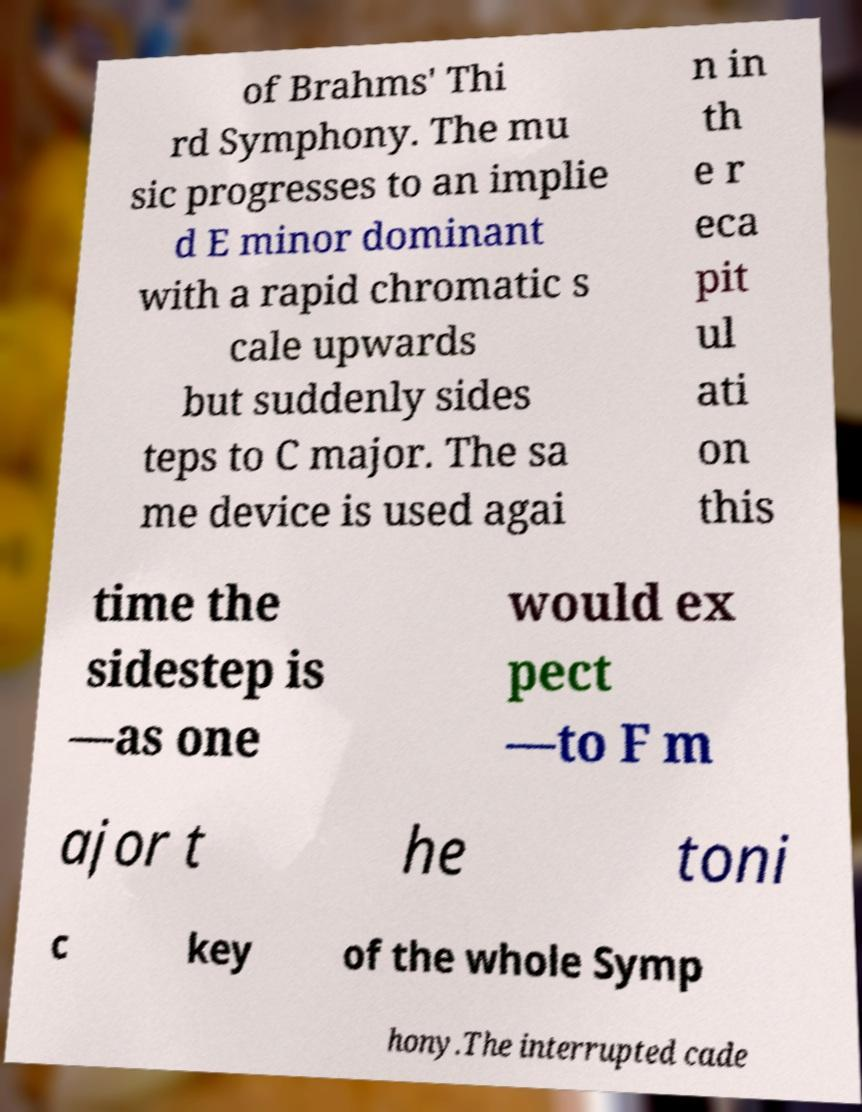Could you extract and type out the text from this image? of Brahms' Thi rd Symphony. The mu sic progresses to an implie d E minor dominant with a rapid chromatic s cale upwards but suddenly sides teps to C major. The sa me device is used agai n in th e r eca pit ul ati on this time the sidestep is —as one would ex pect —to F m ajor t he toni c key of the whole Symp hony.The interrupted cade 